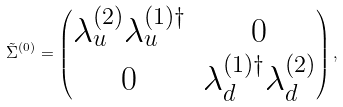Convert formula to latex. <formula><loc_0><loc_0><loc_500><loc_500>\tilde { \Sigma } ^ { ( 0 ) } = \begin{pmatrix} \lambda _ { u } ^ { ( 2 ) } \lambda _ { u } ^ { ( 1 ) \dagger } & 0 \\ 0 & \lambda _ { d } ^ { ( 1 ) \dagger } \lambda _ { d } ^ { ( 2 ) } \end{pmatrix} ,</formula> 